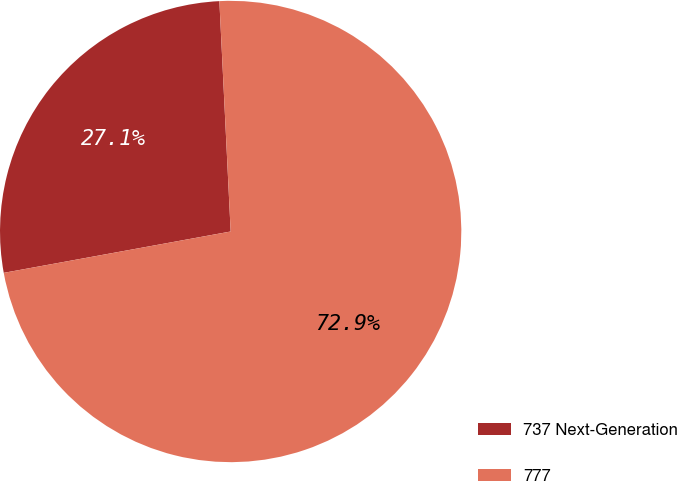Convert chart to OTSL. <chart><loc_0><loc_0><loc_500><loc_500><pie_chart><fcel>737 Next-Generation<fcel>777<nl><fcel>27.09%<fcel>72.91%<nl></chart> 